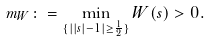<formula> <loc_0><loc_0><loc_500><loc_500>m _ { W } \colon = \min _ { \{ | | s | - 1 | \geq \frac { 1 } { 2 } \} } W ( s ) > 0 .</formula> 